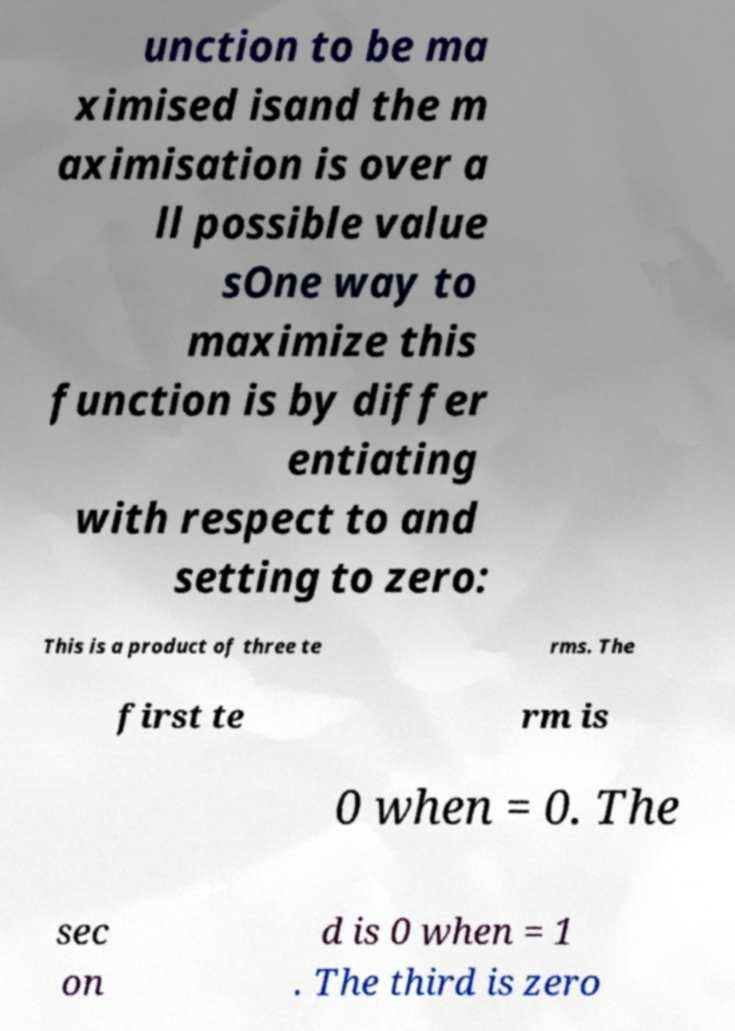There's text embedded in this image that I need extracted. Can you transcribe it verbatim? unction to be ma ximised isand the m aximisation is over a ll possible value sOne way to maximize this function is by differ entiating with respect to and setting to zero: This is a product of three te rms. The first te rm is 0 when = 0. The sec on d is 0 when = 1 . The third is zero 